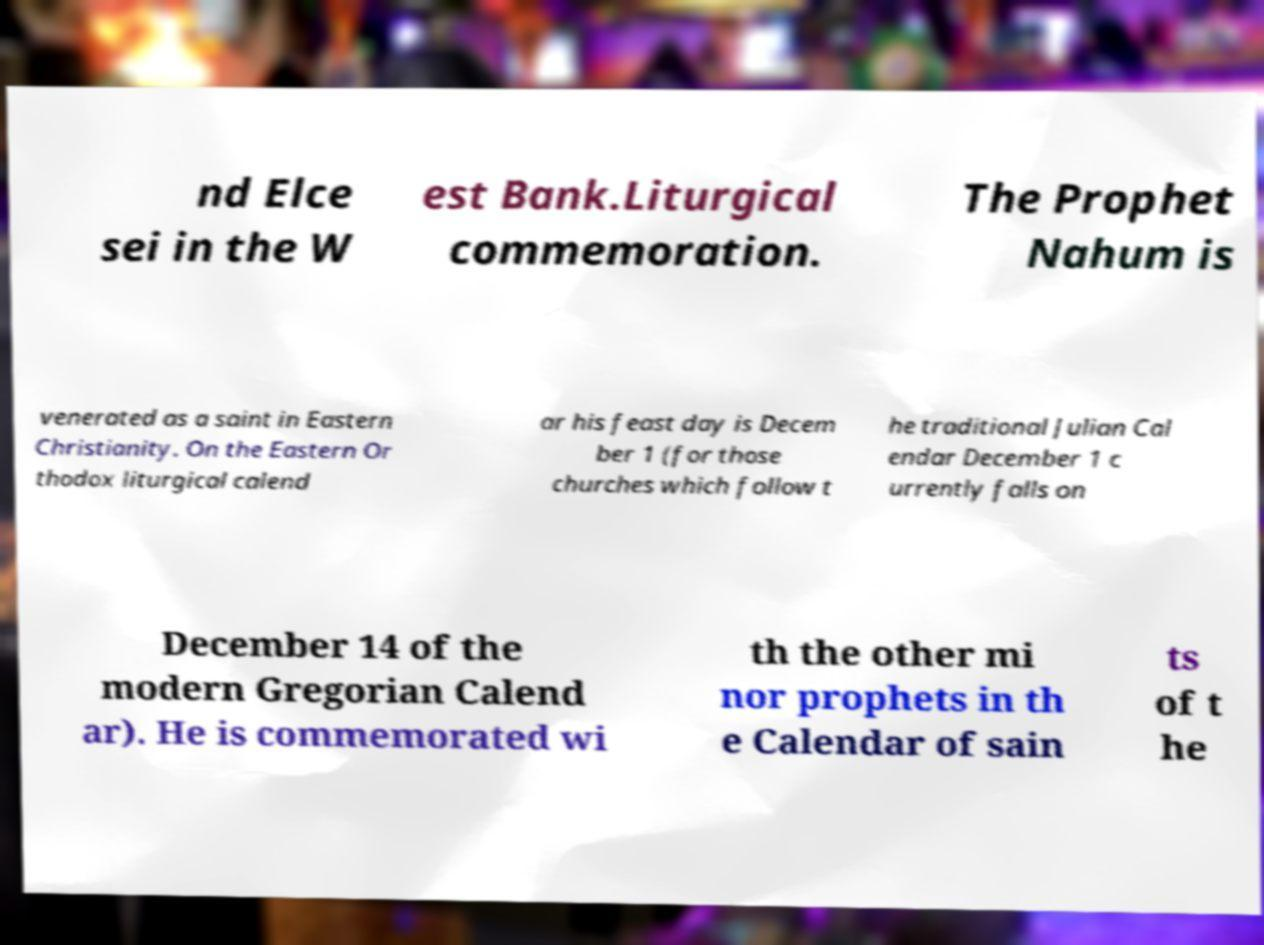Can you read and provide the text displayed in the image?This photo seems to have some interesting text. Can you extract and type it out for me? nd Elce sei in the W est Bank.Liturgical commemoration. The Prophet Nahum is venerated as a saint in Eastern Christianity. On the Eastern Or thodox liturgical calend ar his feast day is Decem ber 1 (for those churches which follow t he traditional Julian Cal endar December 1 c urrently falls on December 14 of the modern Gregorian Calend ar). He is commemorated wi th the other mi nor prophets in th e Calendar of sain ts of t he 